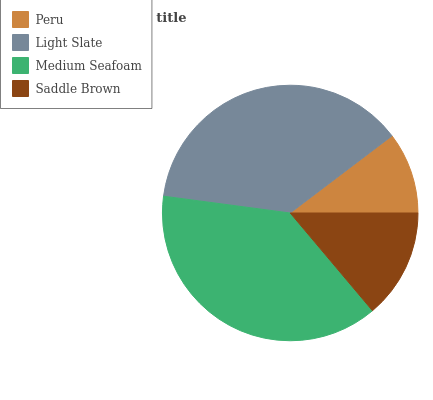Is Peru the minimum?
Answer yes or no. Yes. Is Medium Seafoam the maximum?
Answer yes or no. Yes. Is Light Slate the minimum?
Answer yes or no. No. Is Light Slate the maximum?
Answer yes or no. No. Is Light Slate greater than Peru?
Answer yes or no. Yes. Is Peru less than Light Slate?
Answer yes or no. Yes. Is Peru greater than Light Slate?
Answer yes or no. No. Is Light Slate less than Peru?
Answer yes or no. No. Is Light Slate the high median?
Answer yes or no. Yes. Is Saddle Brown the low median?
Answer yes or no. Yes. Is Peru the high median?
Answer yes or no. No. Is Medium Seafoam the low median?
Answer yes or no. No. 